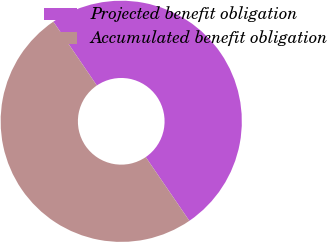Convert chart to OTSL. <chart><loc_0><loc_0><loc_500><loc_500><pie_chart><fcel>Projected benefit obligation<fcel>Accumulated benefit obligation<nl><fcel>49.96%<fcel>50.04%<nl></chart> 